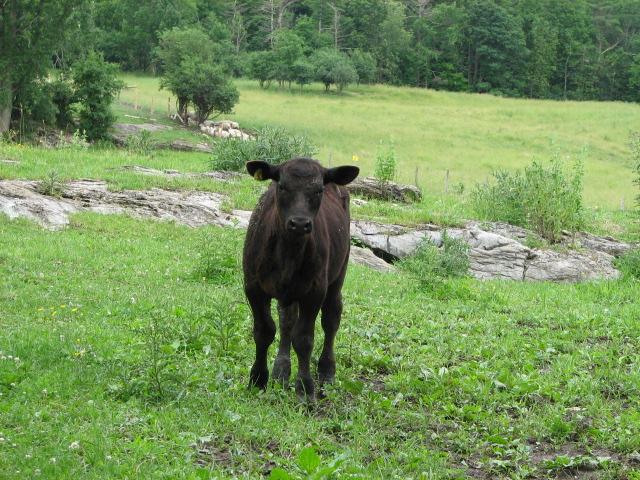How many cows?
Answer briefly. 1. What color is the grass?
Keep it brief. Green. What color is the cow?
Give a very brief answer. Brown. 